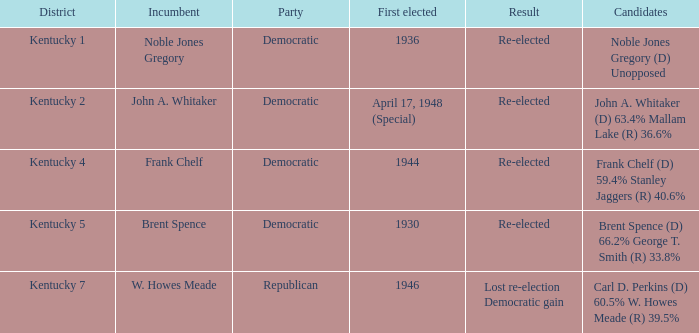What was the outcome of the election incumbent brent spence participated in? Re-elected. 